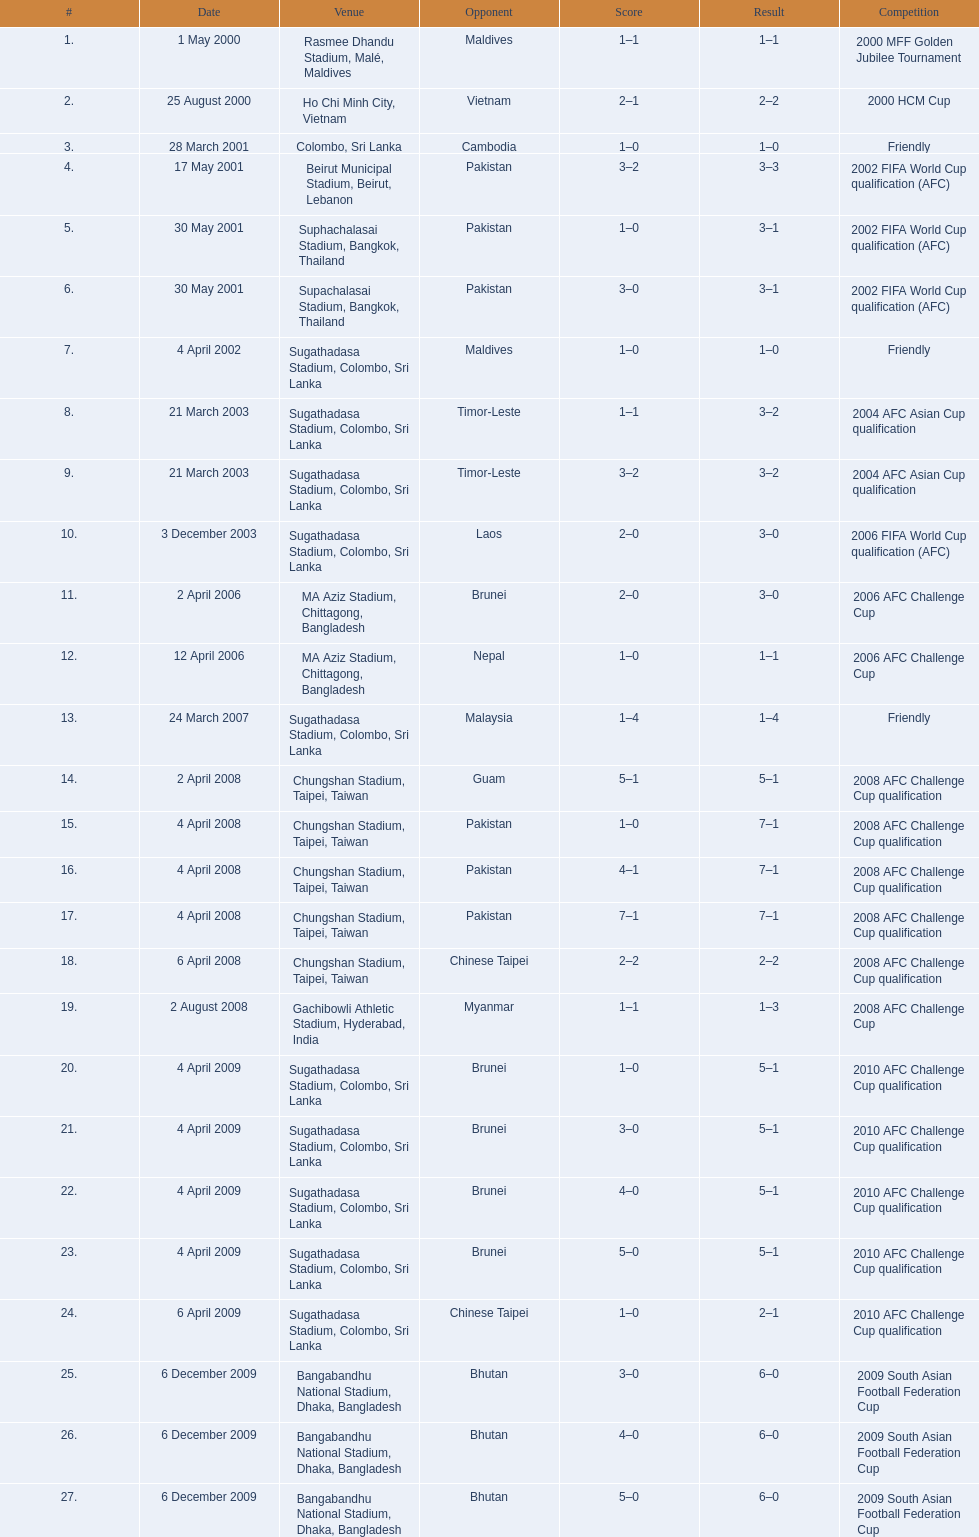Can you provide the venues mentioned? Rasmee Dhandu Stadium, Malé, Maldives, Ho Chi Minh City, Vietnam, Colombo, Sri Lanka, Beirut Municipal Stadium, Beirut, Lebanon, Suphachalasai Stadium, Bangkok, Thailand, MA Aziz Stadium, Chittagong, Bangladesh, Sugathadasa Stadium, Colombo, Sri Lanka, Chungshan Stadium, Taipei, Taiwan, Gachibowli Athletic Stadium, Hyderabad, India, Sugathadasa Stadium, Colombo, Sri Lanka, Bangabandhu National Stadium, Dhaka, Bangladesh. Which one is considered the best among them? Rasmee Dhandu Stadium, Malé, Maldives. 